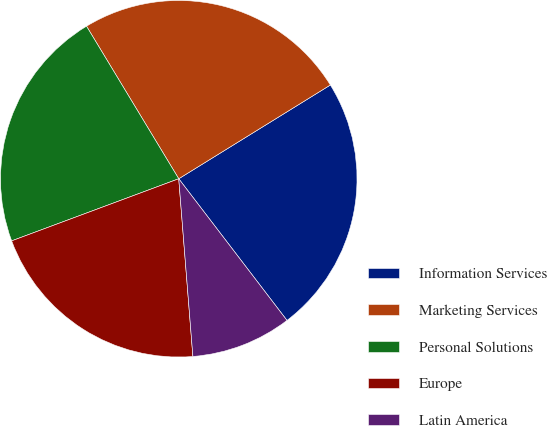<chart> <loc_0><loc_0><loc_500><loc_500><pie_chart><fcel>Information Services<fcel>Marketing Services<fcel>Personal Solutions<fcel>Europe<fcel>Latin America<nl><fcel>23.43%<fcel>24.84%<fcel>22.01%<fcel>20.6%<fcel>9.12%<nl></chart> 